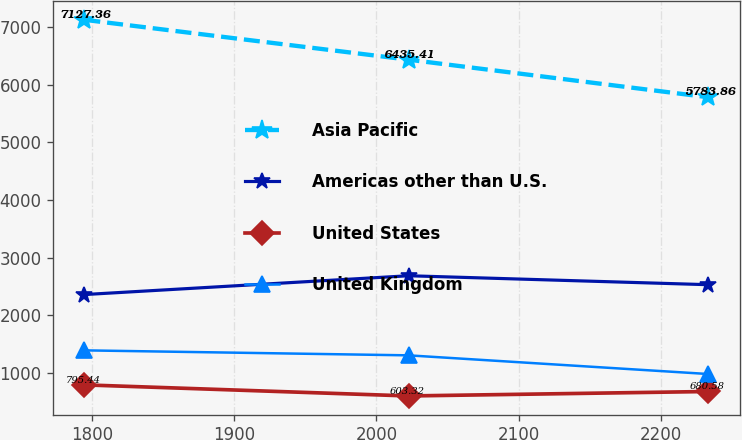<chart> <loc_0><loc_0><loc_500><loc_500><line_chart><ecel><fcel>Asia Pacific<fcel>Americas other than U.S.<fcel>United States<fcel>United Kingdom<nl><fcel>1794.79<fcel>7127.36<fcel>2361.83<fcel>795.44<fcel>1394.06<nl><fcel>2022.56<fcel>6435.41<fcel>2688.15<fcel>603.32<fcel>1307.54<nl><fcel>2233.17<fcel>5783.86<fcel>2532.77<fcel>680.58<fcel>983.47<nl></chart> 